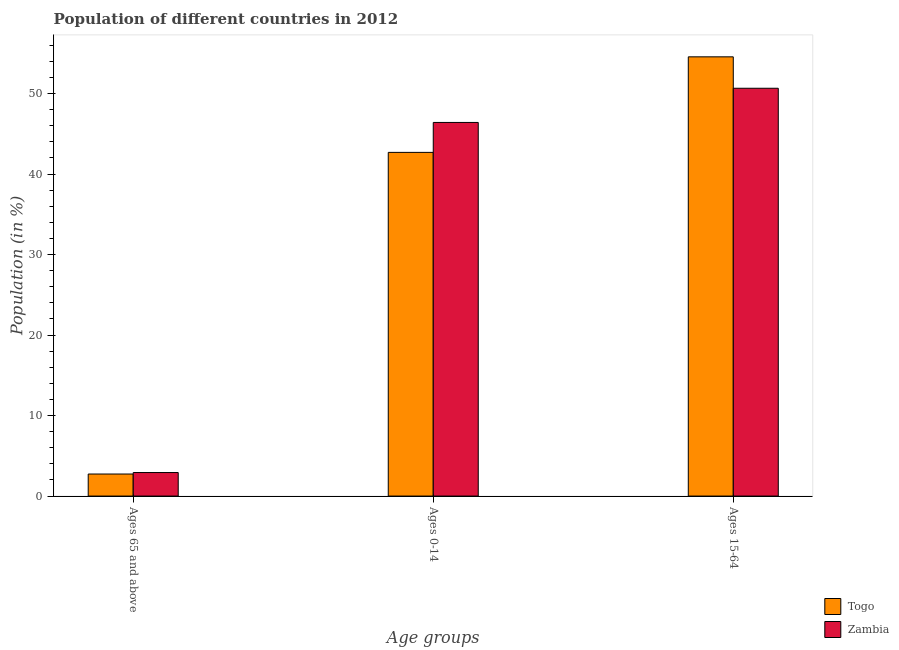Are the number of bars per tick equal to the number of legend labels?
Your response must be concise. Yes. Are the number of bars on each tick of the X-axis equal?
Make the answer very short. Yes. How many bars are there on the 3rd tick from the left?
Provide a short and direct response. 2. What is the label of the 2nd group of bars from the left?
Your answer should be very brief. Ages 0-14. What is the percentage of population within the age-group 15-64 in Zambia?
Make the answer very short. 50.66. Across all countries, what is the maximum percentage of population within the age-group 15-64?
Provide a succinct answer. 54.57. Across all countries, what is the minimum percentage of population within the age-group 0-14?
Provide a short and direct response. 42.7. In which country was the percentage of population within the age-group 0-14 maximum?
Offer a terse response. Zambia. In which country was the percentage of population within the age-group 15-64 minimum?
Your answer should be very brief. Zambia. What is the total percentage of population within the age-group 15-64 in the graph?
Your response must be concise. 105.23. What is the difference between the percentage of population within the age-group 15-64 in Togo and that in Zambia?
Your answer should be compact. 3.9. What is the difference between the percentage of population within the age-group of 65 and above in Zambia and the percentage of population within the age-group 15-64 in Togo?
Your answer should be very brief. -51.64. What is the average percentage of population within the age-group 15-64 per country?
Your answer should be very brief. 52.61. What is the difference between the percentage of population within the age-group 15-64 and percentage of population within the age-group of 65 and above in Togo?
Provide a short and direct response. 51.83. What is the ratio of the percentage of population within the age-group of 65 and above in Togo to that in Zambia?
Offer a terse response. 0.94. Is the difference between the percentage of population within the age-group 15-64 in Togo and Zambia greater than the difference between the percentage of population within the age-group of 65 and above in Togo and Zambia?
Provide a succinct answer. Yes. What is the difference between the highest and the second highest percentage of population within the age-group 15-64?
Offer a terse response. 3.9. What is the difference between the highest and the lowest percentage of population within the age-group of 65 and above?
Your answer should be compact. 0.18. In how many countries, is the percentage of population within the age-group 0-14 greater than the average percentage of population within the age-group 0-14 taken over all countries?
Your response must be concise. 1. What does the 1st bar from the left in Ages 0-14 represents?
Ensure brevity in your answer.  Togo. What does the 1st bar from the right in Ages 15-64 represents?
Keep it short and to the point. Zambia. How many bars are there?
Provide a succinct answer. 6. Does the graph contain any zero values?
Give a very brief answer. No. Does the graph contain grids?
Offer a very short reply. No. How many legend labels are there?
Provide a short and direct response. 2. How are the legend labels stacked?
Your response must be concise. Vertical. What is the title of the graph?
Offer a very short reply. Population of different countries in 2012. What is the label or title of the X-axis?
Make the answer very short. Age groups. What is the label or title of the Y-axis?
Your answer should be very brief. Population (in %). What is the Population (in %) in Togo in Ages 65 and above?
Provide a succinct answer. 2.74. What is the Population (in %) of Zambia in Ages 65 and above?
Provide a succinct answer. 2.92. What is the Population (in %) in Togo in Ages 0-14?
Make the answer very short. 42.7. What is the Population (in %) of Zambia in Ages 0-14?
Provide a short and direct response. 46.42. What is the Population (in %) of Togo in Ages 15-64?
Ensure brevity in your answer.  54.57. What is the Population (in %) in Zambia in Ages 15-64?
Offer a terse response. 50.66. Across all Age groups, what is the maximum Population (in %) in Togo?
Your answer should be very brief. 54.57. Across all Age groups, what is the maximum Population (in %) in Zambia?
Make the answer very short. 50.66. Across all Age groups, what is the minimum Population (in %) of Togo?
Your answer should be very brief. 2.74. Across all Age groups, what is the minimum Population (in %) in Zambia?
Offer a terse response. 2.92. What is the total Population (in %) in Togo in the graph?
Offer a very short reply. 100. What is the total Population (in %) in Zambia in the graph?
Give a very brief answer. 100. What is the difference between the Population (in %) in Togo in Ages 65 and above and that in Ages 0-14?
Provide a short and direct response. -39.96. What is the difference between the Population (in %) of Zambia in Ages 65 and above and that in Ages 0-14?
Make the answer very short. -43.49. What is the difference between the Population (in %) of Togo in Ages 65 and above and that in Ages 15-64?
Offer a terse response. -51.83. What is the difference between the Population (in %) in Zambia in Ages 65 and above and that in Ages 15-64?
Give a very brief answer. -47.74. What is the difference between the Population (in %) in Togo in Ages 0-14 and that in Ages 15-64?
Ensure brevity in your answer.  -11.87. What is the difference between the Population (in %) of Zambia in Ages 0-14 and that in Ages 15-64?
Your answer should be very brief. -4.25. What is the difference between the Population (in %) of Togo in Ages 65 and above and the Population (in %) of Zambia in Ages 0-14?
Ensure brevity in your answer.  -43.68. What is the difference between the Population (in %) in Togo in Ages 65 and above and the Population (in %) in Zambia in Ages 15-64?
Provide a short and direct response. -47.92. What is the difference between the Population (in %) in Togo in Ages 0-14 and the Population (in %) in Zambia in Ages 15-64?
Keep it short and to the point. -7.97. What is the average Population (in %) in Togo per Age groups?
Ensure brevity in your answer.  33.33. What is the average Population (in %) of Zambia per Age groups?
Offer a very short reply. 33.33. What is the difference between the Population (in %) in Togo and Population (in %) in Zambia in Ages 65 and above?
Your response must be concise. -0.18. What is the difference between the Population (in %) of Togo and Population (in %) of Zambia in Ages 0-14?
Make the answer very short. -3.72. What is the difference between the Population (in %) of Togo and Population (in %) of Zambia in Ages 15-64?
Provide a short and direct response. 3.9. What is the ratio of the Population (in %) in Togo in Ages 65 and above to that in Ages 0-14?
Provide a short and direct response. 0.06. What is the ratio of the Population (in %) in Zambia in Ages 65 and above to that in Ages 0-14?
Provide a succinct answer. 0.06. What is the ratio of the Population (in %) in Togo in Ages 65 and above to that in Ages 15-64?
Keep it short and to the point. 0.05. What is the ratio of the Population (in %) of Zambia in Ages 65 and above to that in Ages 15-64?
Provide a succinct answer. 0.06. What is the ratio of the Population (in %) of Togo in Ages 0-14 to that in Ages 15-64?
Keep it short and to the point. 0.78. What is the ratio of the Population (in %) in Zambia in Ages 0-14 to that in Ages 15-64?
Your response must be concise. 0.92. What is the difference between the highest and the second highest Population (in %) of Togo?
Make the answer very short. 11.87. What is the difference between the highest and the second highest Population (in %) in Zambia?
Offer a very short reply. 4.25. What is the difference between the highest and the lowest Population (in %) in Togo?
Ensure brevity in your answer.  51.83. What is the difference between the highest and the lowest Population (in %) in Zambia?
Give a very brief answer. 47.74. 